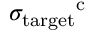Convert formula to latex. <formula><loc_0><loc_0><loc_500><loc_500>\sigma _ { t \arg e t } ^ { c }</formula> 